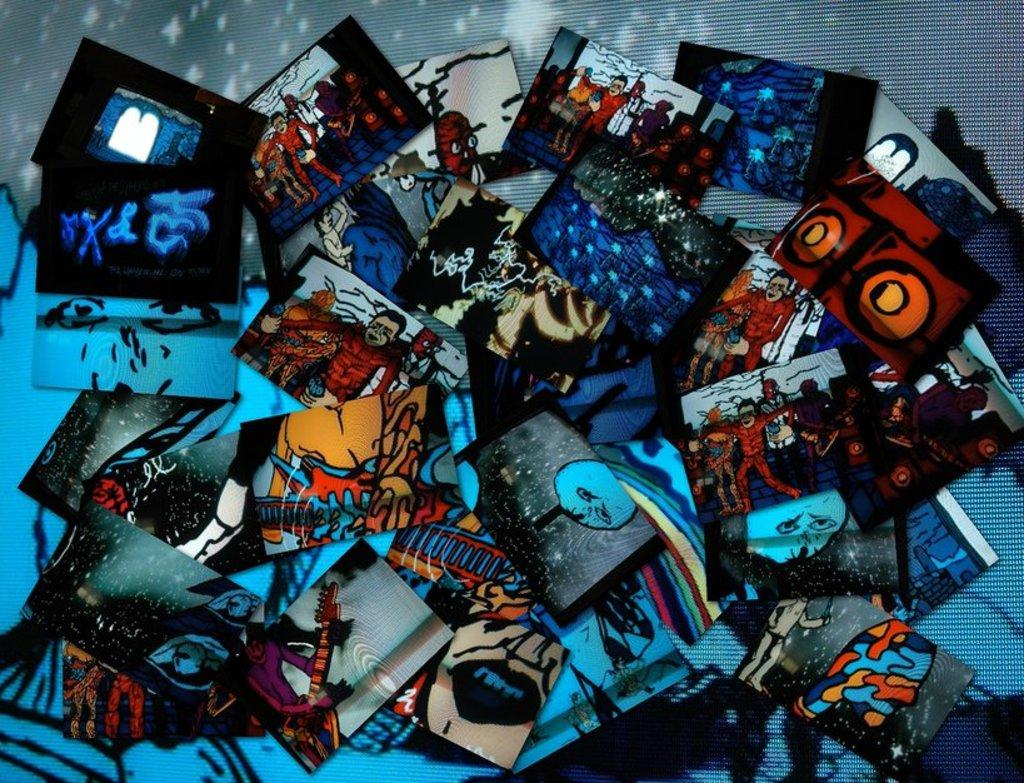What type of visual content is present in the image? The image contains photographs. What type of skirt is being worn by the person in the photograph? There is no person or skirt visible in the image, as it only contains photographs. 